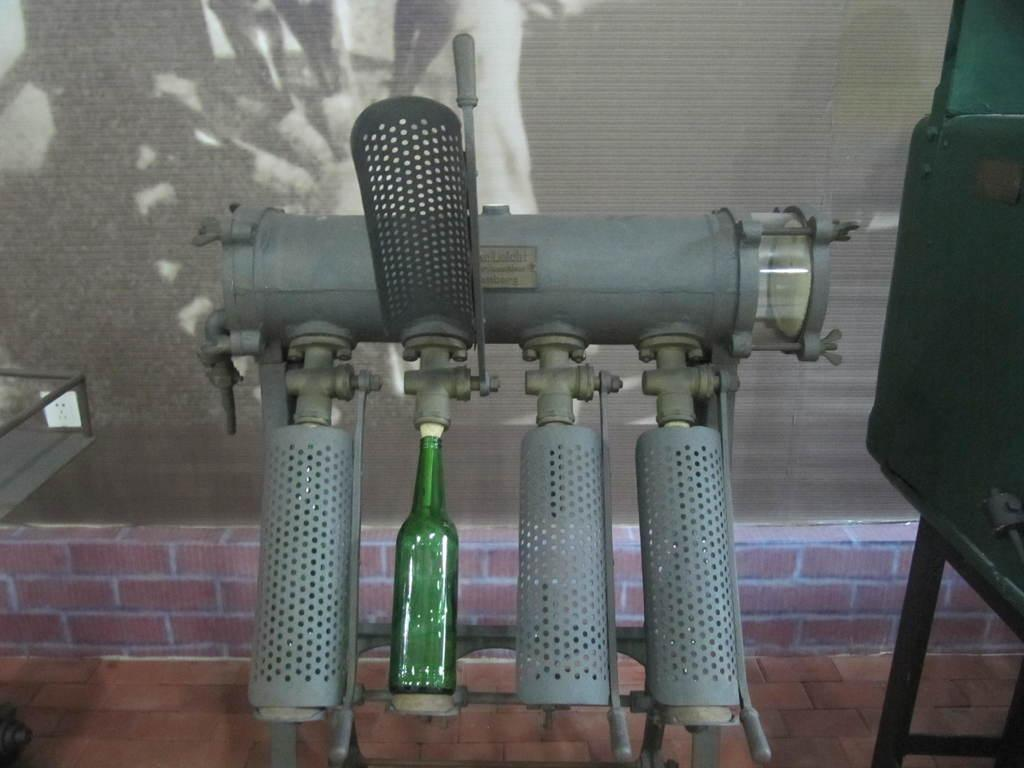What object is present in the image? There is a bottle in the image. What is the bottle placed on? There is a bottle stand in the image. What type of machine might be depicted in the image? The image appears to depict a bottle filling machine. What can be seen in the background of the image? There is a wall in the background of the image. What type of advertisement can be seen on the bottle in the image? There is no advertisement visible on the bottle in the image. What type of stew is being prepared in the image? There is no stew or cooking activity depicted in the image; it shows a bottle filling machine. What is the person's lip doing in the image? There is no person or lips visible in the image. 